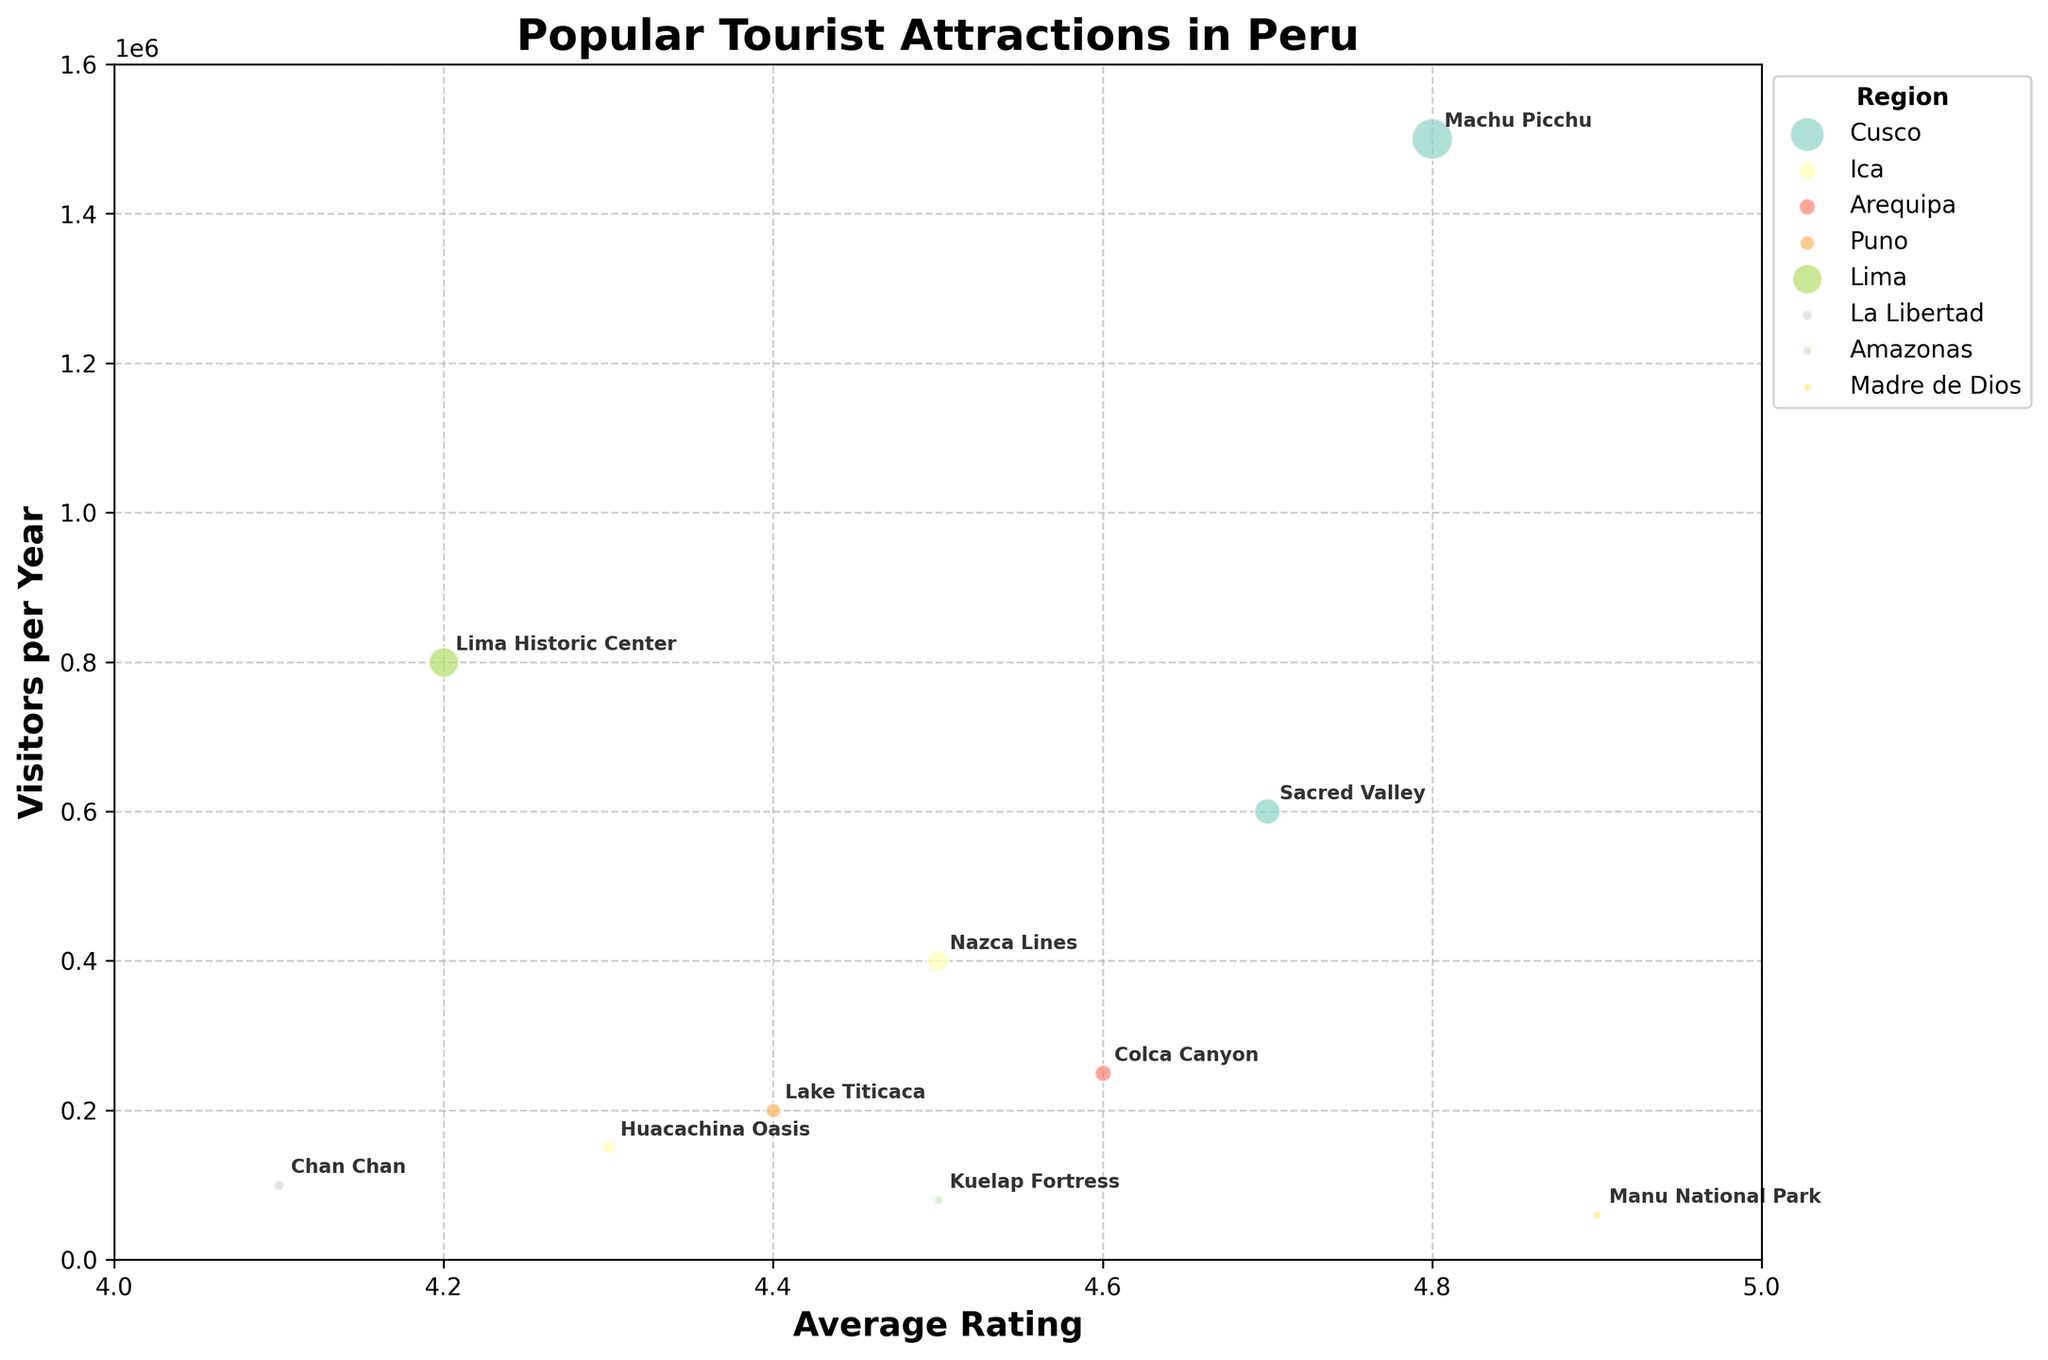Which tourist attraction has the highest average rating? To identify the attraction with the highest average rating, check the x-axis for the furthest right data point. The label closest to this point is "Manu National Park."
Answer: Manu National Park Which attraction receives the most visitors per year? To find the attraction with the most visitors, look at the top of the y-axis. The label closest to the top is "Machu Picchu."
Answer: Machu Picchu What's the average visitor count of attractions in the Cusco region? Cusco attractions are "Machu Picchu" and "Sacred Valley." Their visitor counts are 1,500,000 and 600,000, respectively. Calculate the average: (1,500,000 + 600,000) / 2.
Answer: 1,050,000 How many attractions have an average rating of 4.5? Count the number of data points located on the x-axis at 4.5. The labels are "Nazca Lines" and "Kuelap Fortress."
Answer: 2 Which regions have attractions with average ratings above 4.6? Look along the x-axis above 4.6 to see these attractions and regions. They include "Machu Picchu" (Cusco), "Sacred Valley" (Cusco), "Colca Canyon" (Arequipa), and "Manu National Park" (Madre de Dios).
Answer: Cusco, Arequipa, Madre de Dios What’s the difference in visitor count between the attractions in Lima and Madre de Dios? The attractions are "Lima Historic Center" (800,000 visitors) and "Manu National Park" (60,000 visitors). Calculate the difference: 800,000 - 60,000.
Answer: 740,000 Which attraction has the lowest visitor count but a high average rating? Identify the lowest point on the y-axis and then check which attractions have high ratings on the x-axis. "Manu National Park" has the lowest visitor count (60,000) but a high rating (4.9).
Answer: Manu National Park How many regions are represented in the plot? Count the unique regions in the legend. The regions are Cusco, Ica, Arequipa, Puno, Lima, La Libertad, Amazonas, and Madre de Dios.
Answer: 8 Which region has the most tourist attractions listed in the plot? Evaluate the labels and regions of each data point in the plot. The region with the most labels is Cusco, with "Machu Picchu" and "Sacred Valley."
Answer: Cusco 